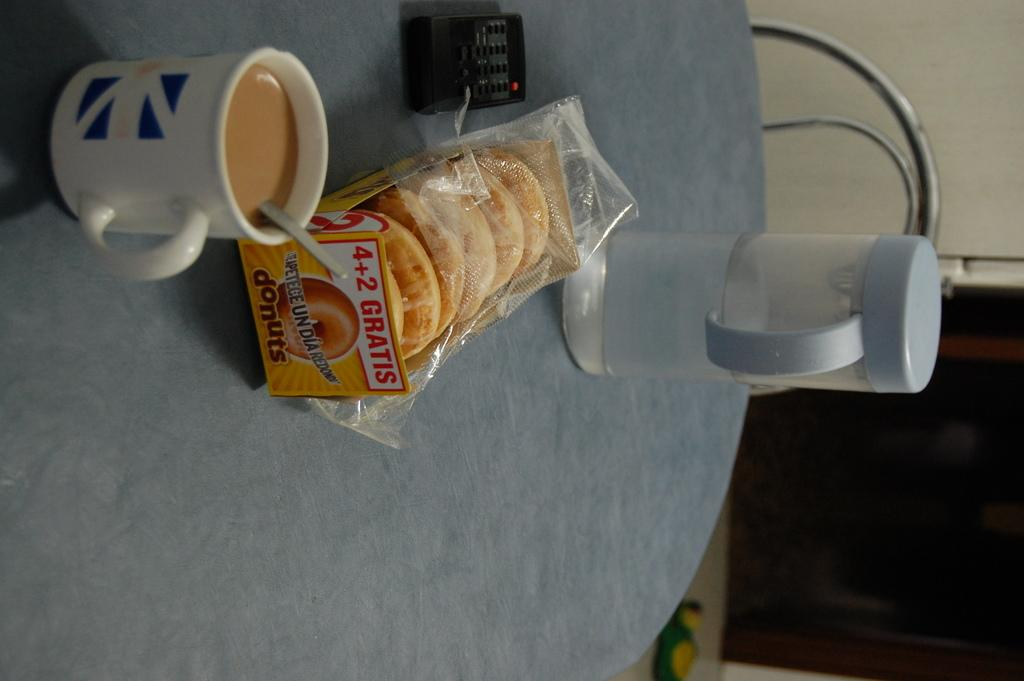<image>
Write a terse but informative summary of the picture. a package of donuts next to a coffee on the table 